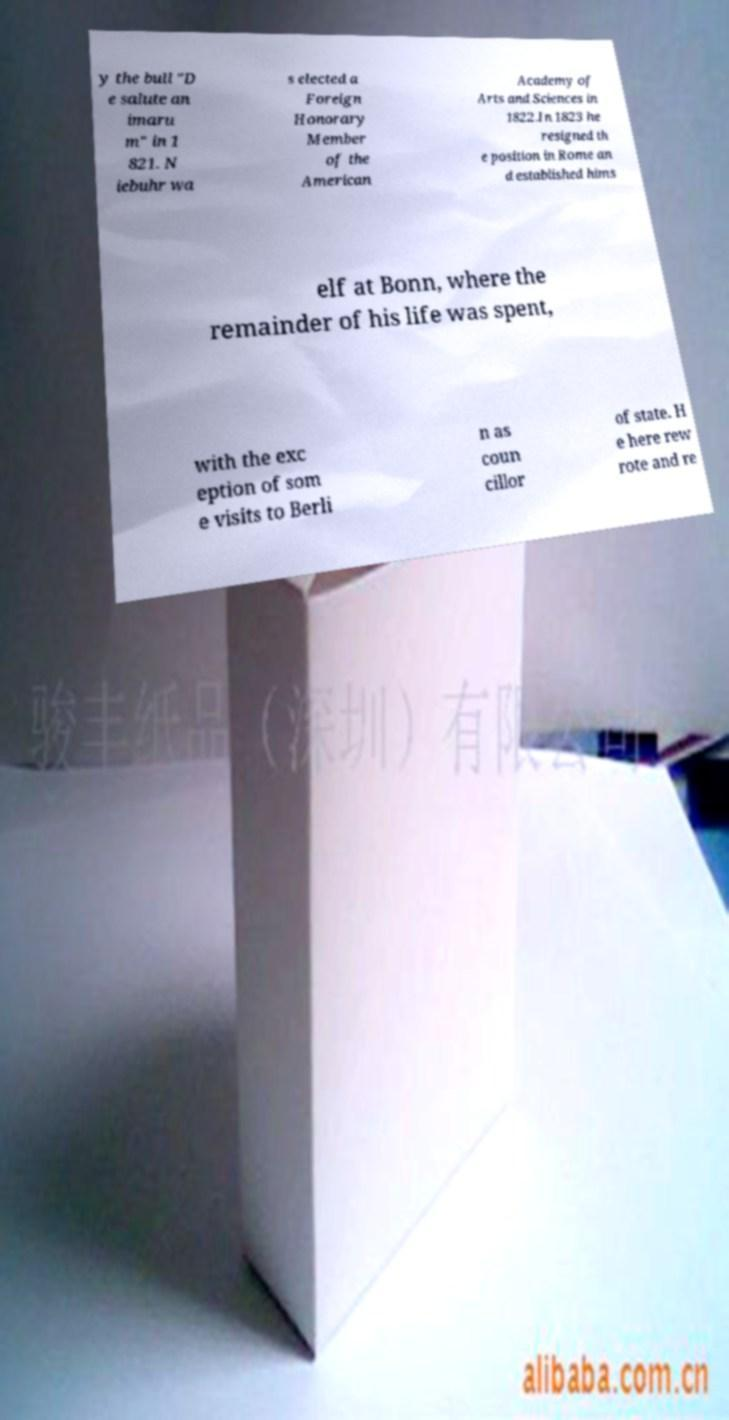What messages or text are displayed in this image? I need them in a readable, typed format. y the bull "D e salute an imaru m" in 1 821. N iebuhr wa s elected a Foreign Honorary Member of the American Academy of Arts and Sciences in 1822.In 1823 he resigned th e position in Rome an d established hims elf at Bonn, where the remainder of his life was spent, with the exc eption of som e visits to Berli n as coun cillor of state. H e here rew rote and re 